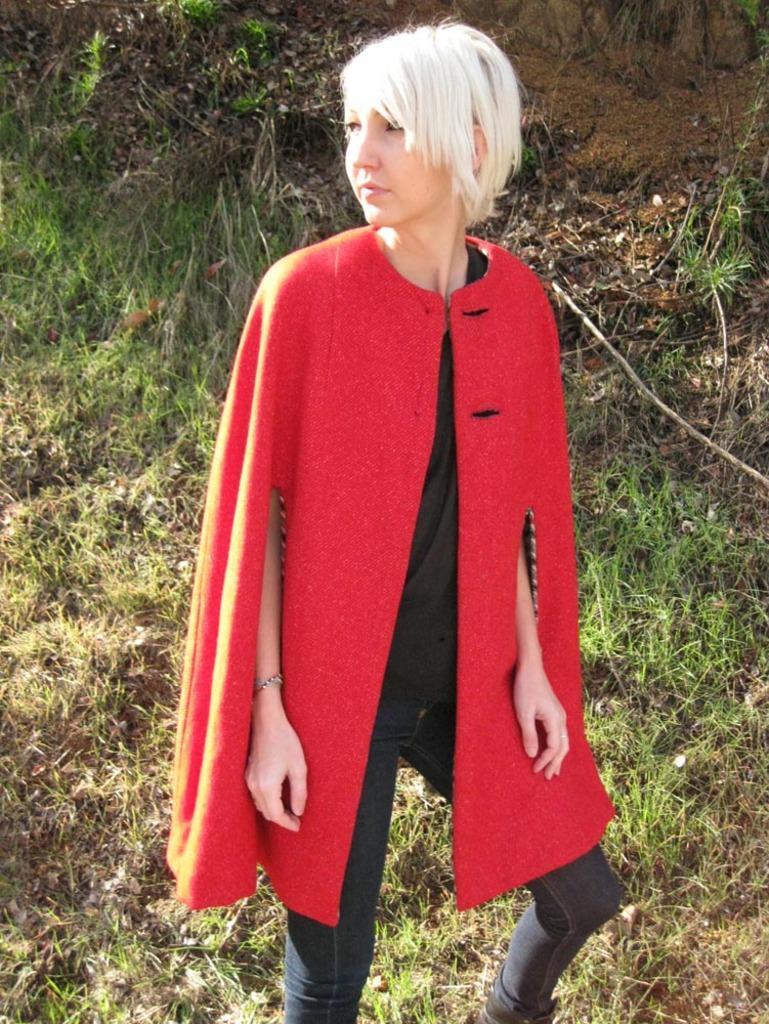Describe this image in one or two sentences. In the center of the image we can see a lady is standing and wearing a coat, jeans. In the background of the image we can see the grass. At the bottom of the image we can see the ground. 